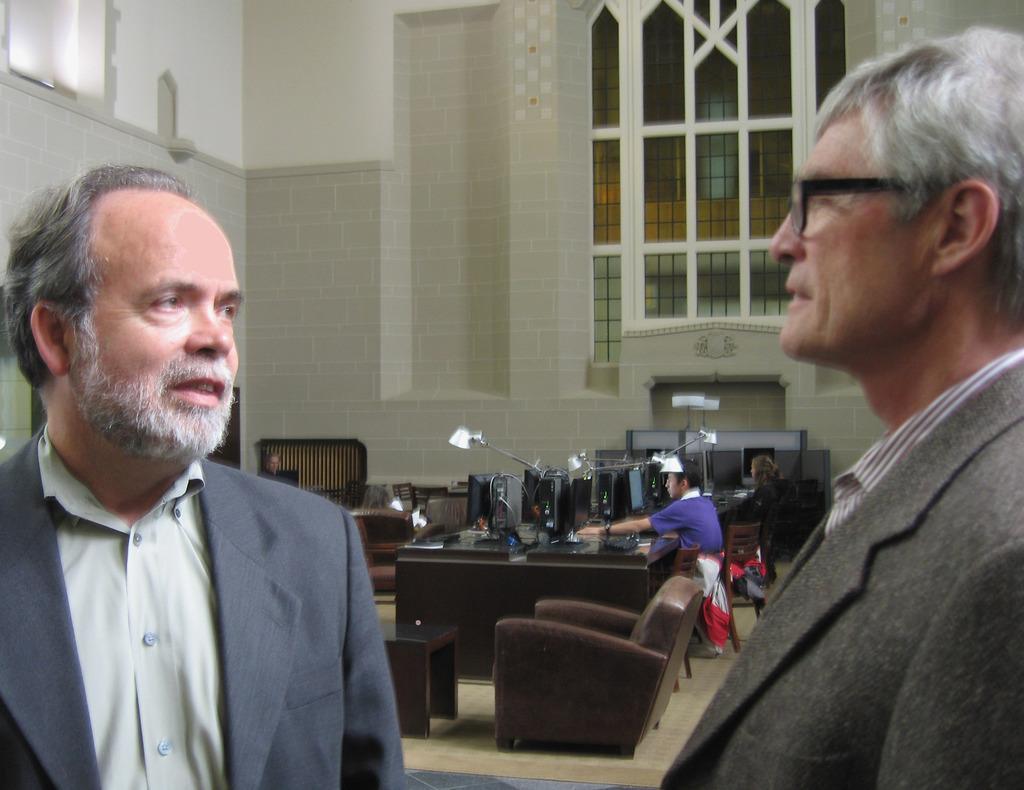Could you give a brief overview of what you see in this image? This image is clicked in a room. There are two persons one is on the right side and the other one is on the left side. There is a table and chairs. On the table there is a light, laptop and book. There is a person sitting on chair near the table. 